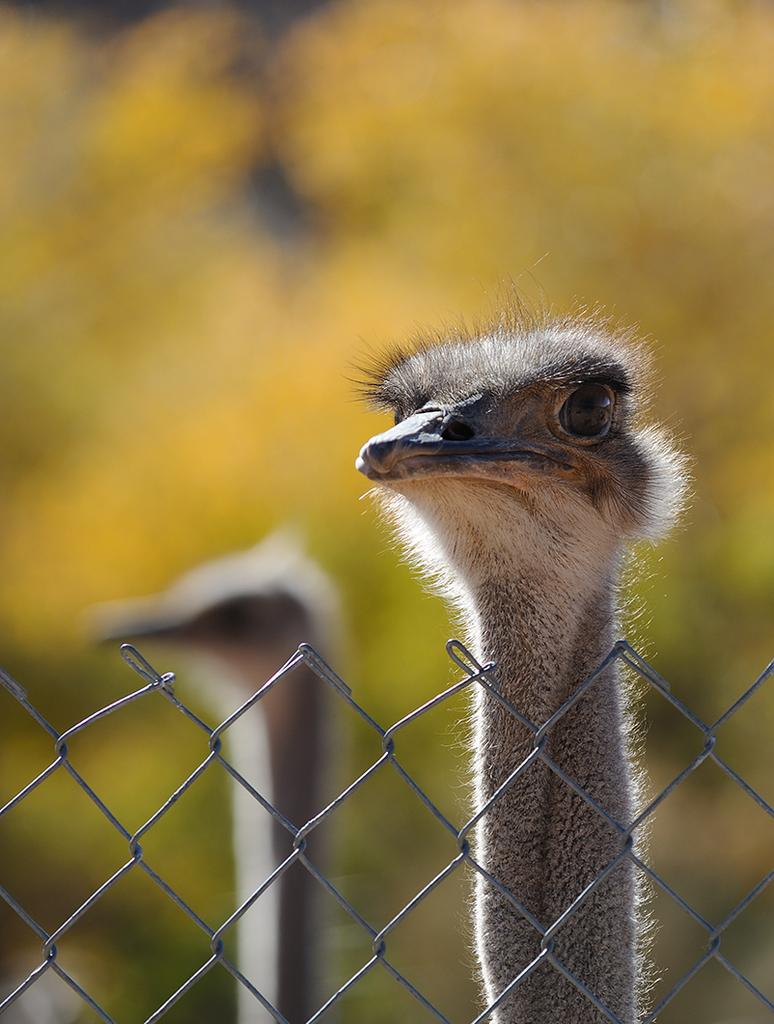What animals are featured in the image? There are two ostrich heads in the image. What can be seen in the foreground of the image? There is a fence in the image. How would you describe the background of the image? The background of the image is blurred. How many women are helping the ostriches in the image? There are no women present in the image, and the ostriches do not require help. 